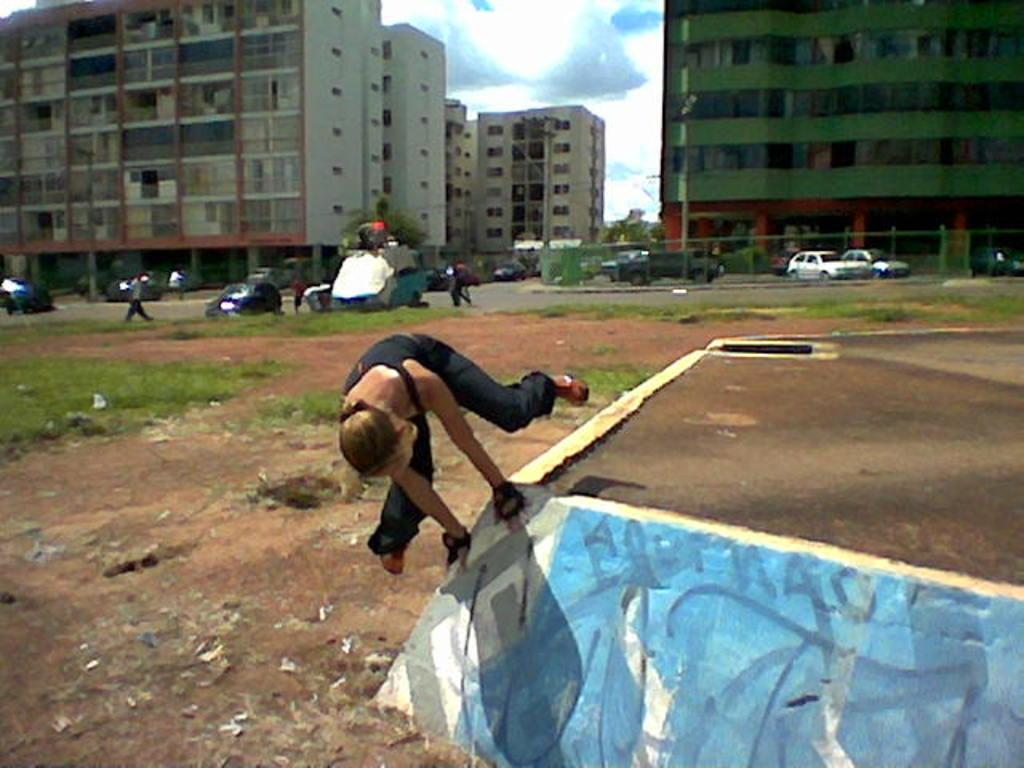What is happening in the image involving a person? There is a person in the image doing something on the ground. What can be seen in the background of the image? There are many buildings, vehicles, and trees in the background of the image. What type of ear is visible on the person in the image? There is no ear visible on the person in the image, as the person's face is not shown. --- Facts: 1. There is a person in the image. 2. The person is holding a book. 3. The person is sitting on a chair. 4. There is a table in the image. 5. The table has a lamp on it. Absurd Topics: parrot, ocean, dance Conversation: What is the person in the image doing? The person in the image is holding a book. What is the person sitting on? The person is sitting on a chair. What can be seen on the table in the image? There is a lamp on the table in the image. Reasoning: Let's think step by step in order to produce the conversation. We start by identifying the main subject in the image, which is the person. Then, we describe what the person is doing, which is holding a book. Next, we mention the person's position, sitting on a chair. Finally, we expand the conversation to include the table and the lamp on it. Absurd Question/Answer: Can you see a parrot dancing on the ocean in the image? No, there is no parrot or ocean present in the image. 